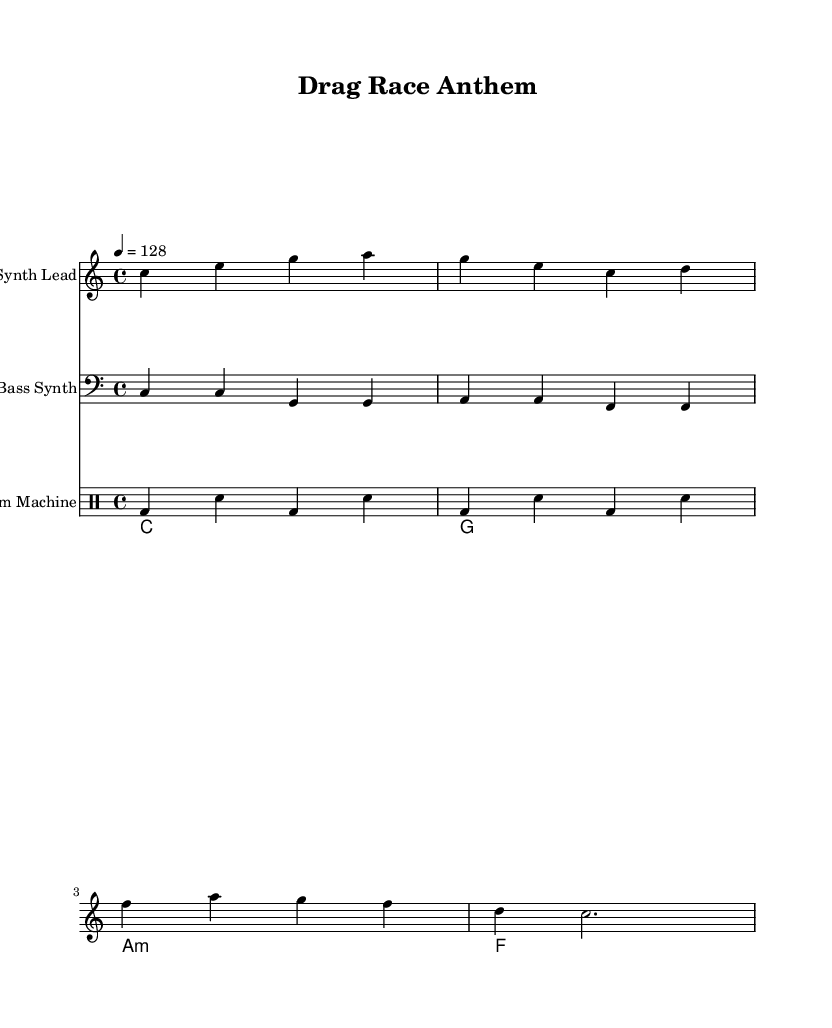What is the key signature of this music? The key signature is C major, which has no sharps or flats.
Answer: C major What is the time signature of this piece? The time signature shown at the beginning of the score is 4/4, indicating four beats per measure.
Answer: 4/4 What is the tempo marking? The tempo marking indicates the piece should be played at a speed of 128 beats per minute.
Answer: 128 How many measures are in the synth lead section? Counting the measures in the synth lead part, there are a total of four measures present.
Answer: 4 Which instrument is playing the bass part? The bass part is specifically notated for a Bass Synth in the music sheet.
Answer: Bass Synth How is the drum pattern structured? The drum part features a kick drum and snare alternating every two beats, forming a repetitive pattern typical of dance music.
Answer: Alternating kick and snare What is the predominant chord used in the chord progression? The chord progression predominantly moves from the tonic chord C major, creating a bright and upbeat feel throughout the piece.
Answer: C 